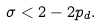Convert formula to latex. <formula><loc_0><loc_0><loc_500><loc_500>\sigma < 2 - 2 p _ { d } .</formula> 